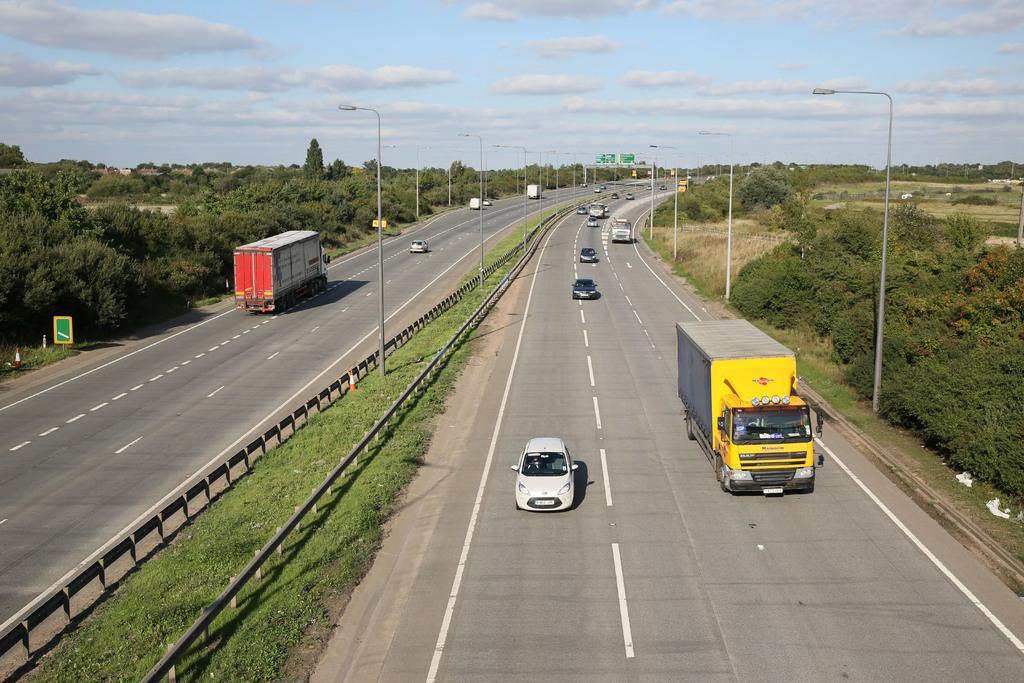Describe this image in one or two sentences. In this image I can see a road and number of vehicles on it. I can also see street lights and trees. In the background I can see sky with some clouds. 